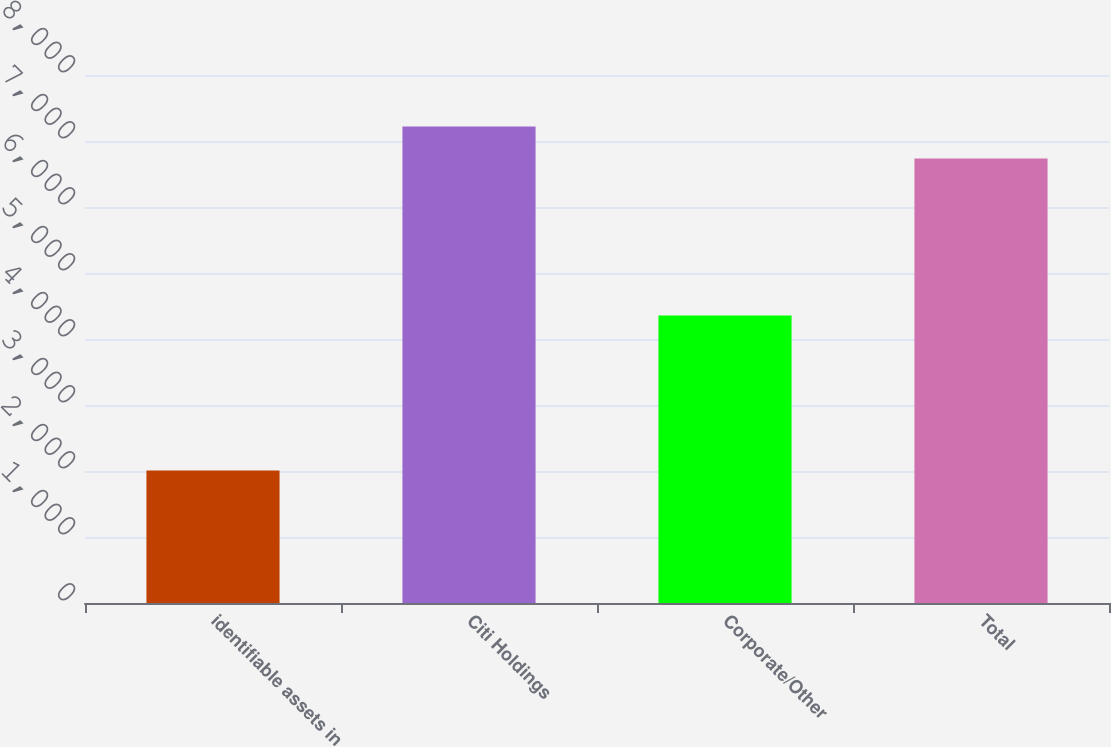<chart> <loc_0><loc_0><loc_500><loc_500><bar_chart><fcel>identifiable assets in<fcel>Citi Holdings<fcel>Corporate/Other<fcel>Total<nl><fcel>2009<fcel>7219.9<fcel>4356<fcel>6733<nl></chart> 